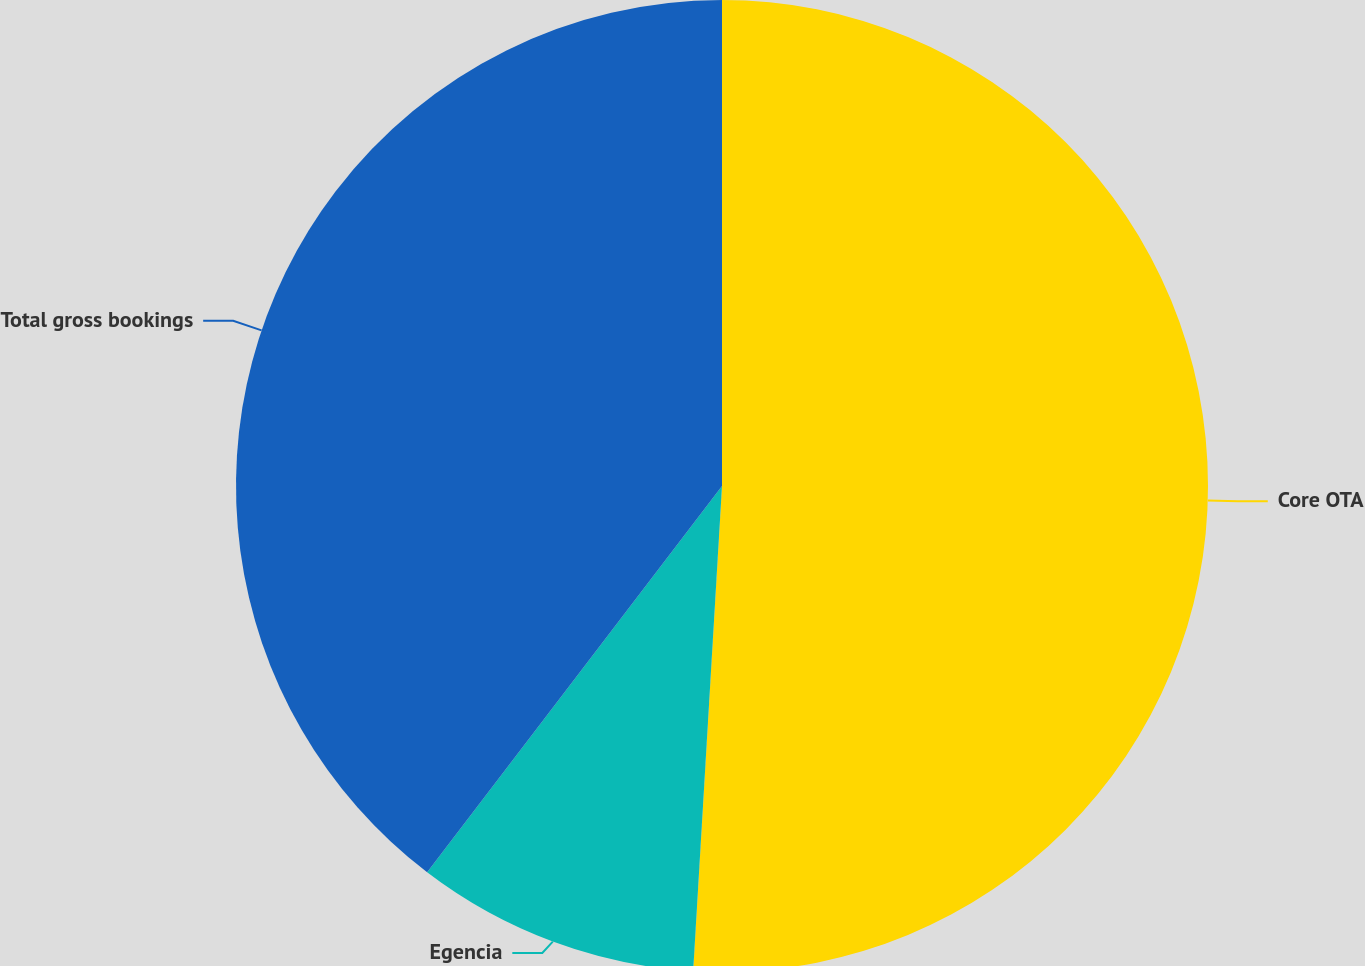<chart> <loc_0><loc_0><loc_500><loc_500><pie_chart><fcel>Core OTA<fcel>Egencia<fcel>Total gross bookings<nl><fcel>50.94%<fcel>9.43%<fcel>39.62%<nl></chart> 